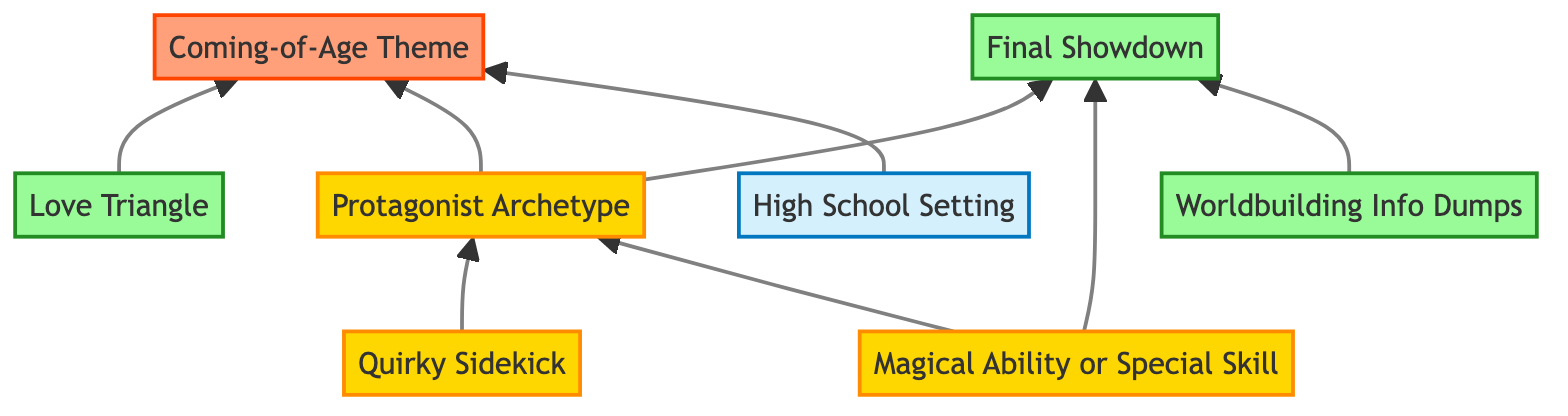What is the primary setting used in many light novel adaptations? The diagram identifies "High School Setting" as a central theme. This node indicates the most common backdrop for many light novels.
Answer: High School Setting How many character types are represented in the diagram? The diagram lists three character types: "Protagonist Archetype," "Quirky Sidekick," and "Magical Ability or Special Skill." Adding these gives a total of three character types.
Answer: 3 Which plot element is associated with three characters generating tension? The "Love Triangle" node specifically describes a recurring romantic subplot involving three characters, indicating this as a crucial plot element.
Answer: Love Triangle What is the relationship between the "Magical Ability or Special Skill" and "Protagonist Archetype"? The flowchart shows a directed edge from "Magical Ability or Special Skill" to "Protagonist Archetype," meaning that it is a trait that tends to be connected to the protagonist.
Answer: Protagonist Archetype Which plot structure concludes the adaptations, representing a confrontation? The "Final Showdown" node signifies that it is the climax and confronts the protagonist with the main antagonist, particularly at the end of the story arc.
Answer: Final Showdown What theme is emphasized alongside the "High School Setting" and "Protagonist Archetype"? The "Coming-of-Age Theme" is shown to be linked to both the "High School Setting" and "Protagonist Archetype," suggesting a focus on personal growth through these aspects.
Answer: Coming-of-Age Theme What character type is often known for providing comic relief? The node "Quirky Sidekick" describes a character who often adds humor and eccentricity, highlighting this character type's role as comic relief in the narrative.
Answer: Quirky Sidekick How many plot devices does the diagram categorize? There are two identified plot devices: "Love Triangle" and "Worldbuilding Info Dumps." Thus, the total number of plot devices in the diagram is two.
Answer: 2 